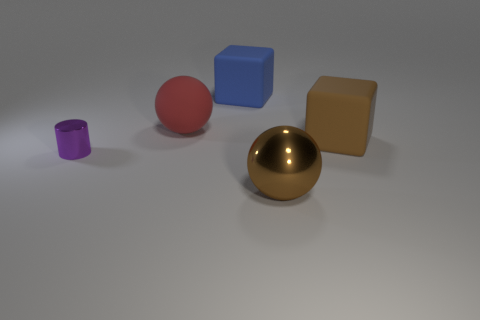Is there anything else that has the same size as the metal cylinder?
Keep it short and to the point. No. The rubber cube that is the same color as the big metal sphere is what size?
Your answer should be very brief. Large. Do the ball that is to the right of the big blue object and the matte cube that is in front of the big blue cube have the same size?
Provide a short and direct response. Yes. How many other things are the same shape as the tiny purple object?
Provide a succinct answer. 0. What is the material of the tiny cylinder to the left of the big brown object that is on the left side of the brown rubber object?
Offer a terse response. Metal. How many matte things are large green things or red objects?
Your answer should be very brief. 1. Are there any purple shiny cylinders that are left of the big brown thing in front of the metal cylinder?
Your answer should be compact. Yes. How many objects are either large objects that are in front of the large blue cube or big brown objects that are behind the shiny cylinder?
Give a very brief answer. 3. Is there anything else that is the same color as the big shiny ball?
Offer a very short reply. Yes. There is a big sphere in front of the brown object that is behind the brown metallic sphere that is in front of the large matte sphere; what color is it?
Offer a terse response. Brown. 